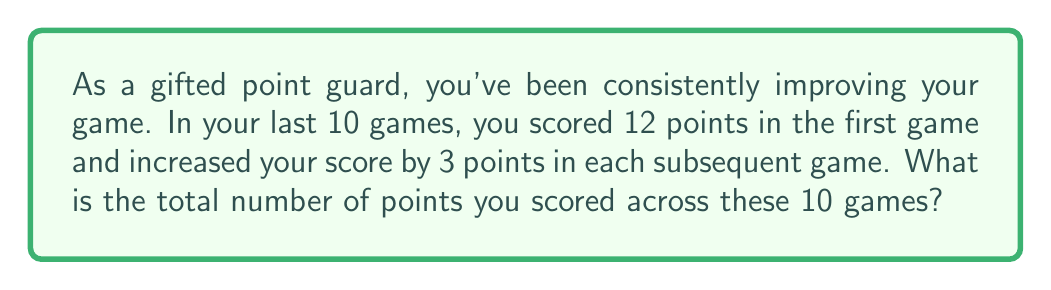Could you help me with this problem? Let's approach this step-by-step using the arithmetic sequence formula:

1) First, identify the components of the arithmetic sequence:
   $a_1 = 12$ (first term)
   $d = 3$ (common difference)
   $n = 10$ (number of terms)

2) The last term $a_n$ can be calculated using the formula:
   $a_n = a_1 + (n-1)d$
   $a_{10} = 12 + (10-1)3 = 12 + 27 = 39$

3) For an arithmetic sequence, the sum $S_n$ is given by:
   $S_n = \frac{n}{2}(a_1 + a_n)$

4) Substituting our values:
   $S_{10} = \frac{10}{2}(12 + 39)$
   $S_{10} = 5(51)$
   $S_{10} = 255$

Therefore, the total number of points scored across the 10 games is 255.

This result shows your consistent improvement, increasing from 12 points in the first game to 39 points in the tenth game, with a total of 255 points over the 10-game stretch.
Answer: 255 points 